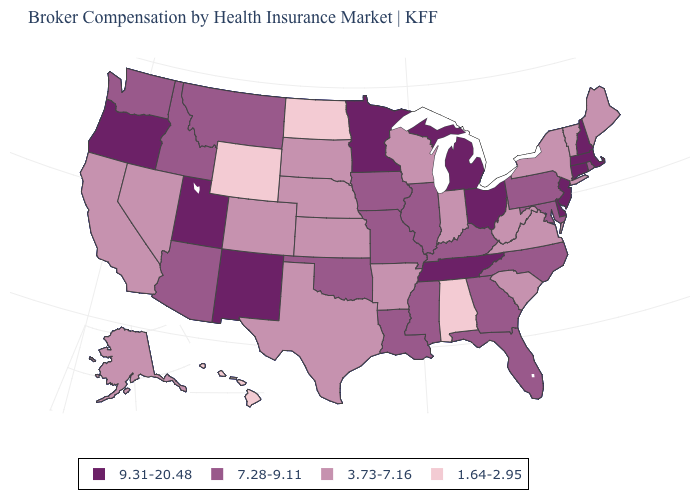Among the states that border Maryland , which have the highest value?
Write a very short answer. Delaware. Does the first symbol in the legend represent the smallest category?
Quick response, please. No. What is the value of Idaho?
Keep it brief. 7.28-9.11. What is the value of Wisconsin?
Keep it brief. 3.73-7.16. Does Minnesota have the highest value in the MidWest?
Concise answer only. Yes. What is the highest value in the USA?
Be succinct. 9.31-20.48. How many symbols are there in the legend?
Answer briefly. 4. Which states hav the highest value in the MidWest?
Short answer required. Michigan, Minnesota, Ohio. How many symbols are there in the legend?
Write a very short answer. 4. Name the states that have a value in the range 7.28-9.11?
Give a very brief answer. Arizona, Florida, Georgia, Idaho, Illinois, Iowa, Kentucky, Louisiana, Maryland, Mississippi, Missouri, Montana, North Carolina, Oklahoma, Pennsylvania, Rhode Island, Washington. What is the value of Nebraska?
Be succinct. 3.73-7.16. Name the states that have a value in the range 1.64-2.95?
Quick response, please. Alabama, Hawaii, North Dakota, Wyoming. Does the map have missing data?
Quick response, please. No. What is the highest value in the Northeast ?
Quick response, please. 9.31-20.48. What is the lowest value in the USA?
Keep it brief. 1.64-2.95. 